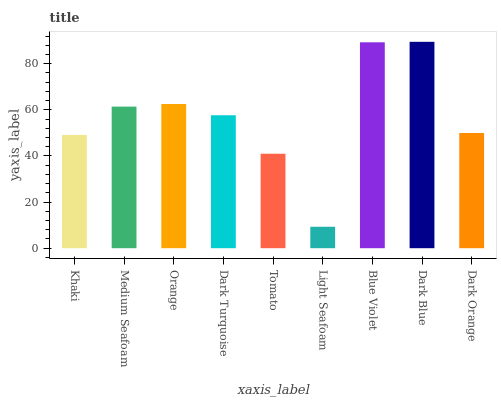Is Light Seafoam the minimum?
Answer yes or no. Yes. Is Dark Blue the maximum?
Answer yes or no. Yes. Is Medium Seafoam the minimum?
Answer yes or no. No. Is Medium Seafoam the maximum?
Answer yes or no. No. Is Medium Seafoam greater than Khaki?
Answer yes or no. Yes. Is Khaki less than Medium Seafoam?
Answer yes or no. Yes. Is Khaki greater than Medium Seafoam?
Answer yes or no. No. Is Medium Seafoam less than Khaki?
Answer yes or no. No. Is Dark Turquoise the high median?
Answer yes or no. Yes. Is Dark Turquoise the low median?
Answer yes or no. Yes. Is Khaki the high median?
Answer yes or no. No. Is Dark Orange the low median?
Answer yes or no. No. 